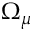Convert formula to latex. <formula><loc_0><loc_0><loc_500><loc_500>\Omega _ { \mu }</formula> 